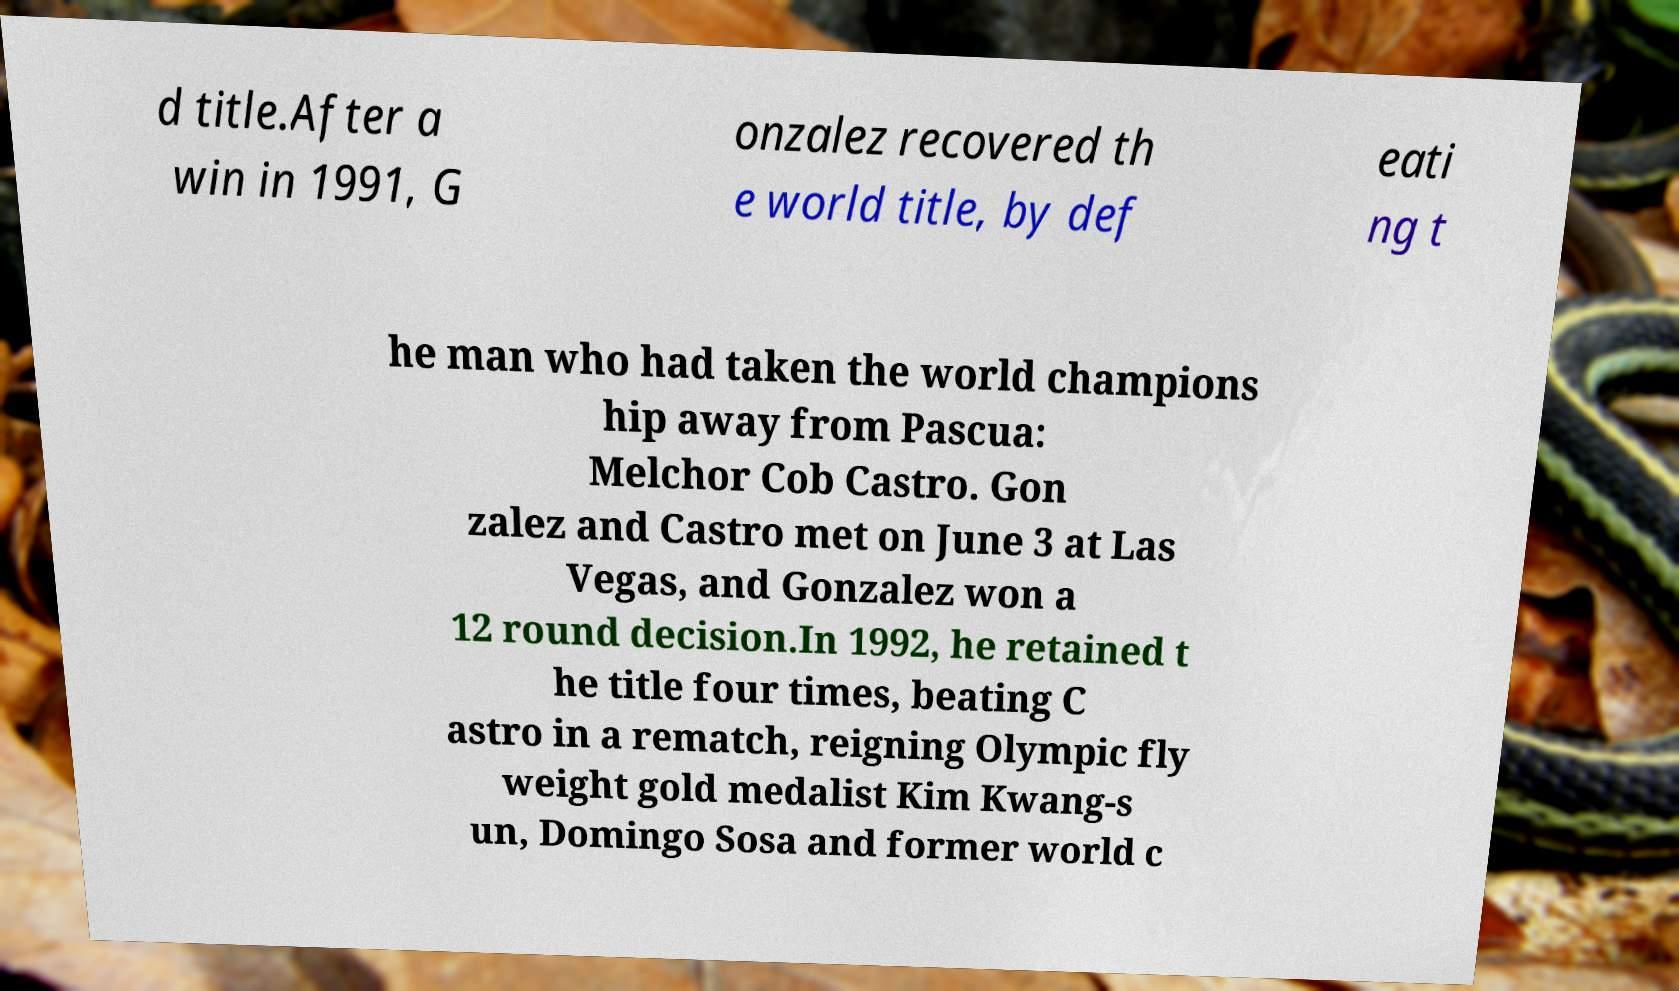Please identify and transcribe the text found in this image. d title.After a win in 1991, G onzalez recovered th e world title, by def eati ng t he man who had taken the world champions hip away from Pascua: Melchor Cob Castro. Gon zalez and Castro met on June 3 at Las Vegas, and Gonzalez won a 12 round decision.In 1992, he retained t he title four times, beating C astro in a rematch, reigning Olympic fly weight gold medalist Kim Kwang-s un, Domingo Sosa and former world c 